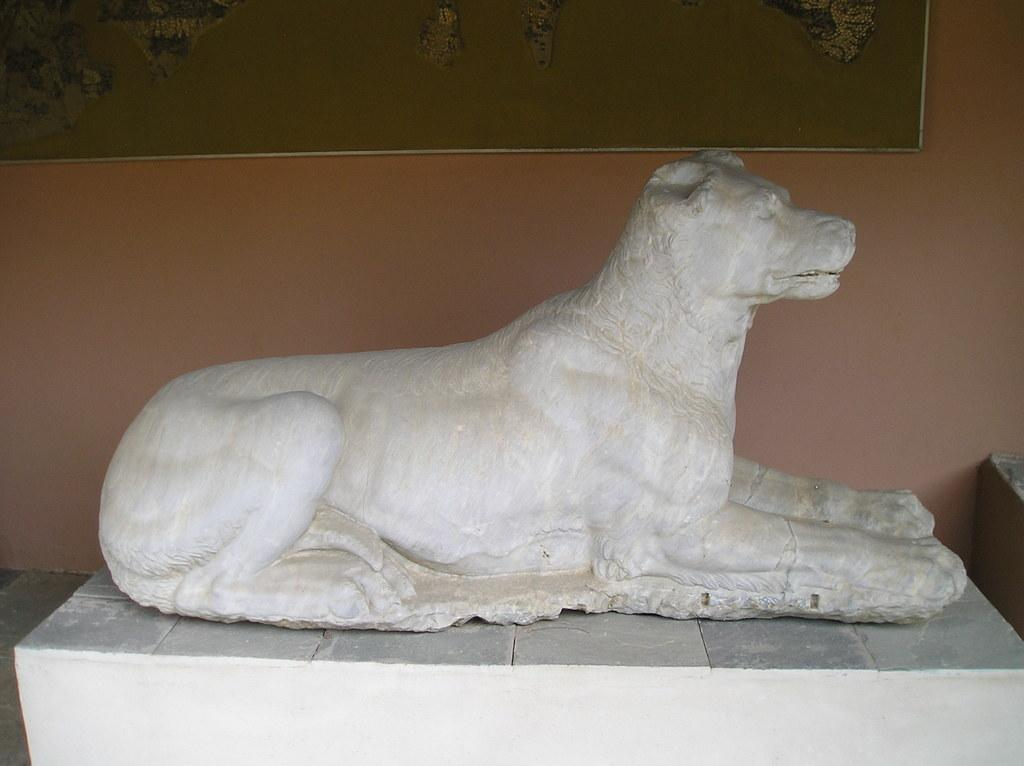What is the main subject in the foreground of the image? There is a statue of an animal in the foreground of the image. What can be seen on the wall in the background of the image? There is a board on the wall in the background of the image. What type of surface is visible in the image? There is a floor visible in the image. What type of cactus is visible in the image? There is no cactus present in the image. Can you tell me if the friend of the statue is also in the image? The concept of a statue having a friend is not applicable in this context, as the statue is an inanimate object. 